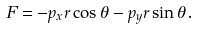<formula> <loc_0><loc_0><loc_500><loc_500>F = - p _ { x } r \cos \theta - p _ { y } r \sin \theta .</formula> 